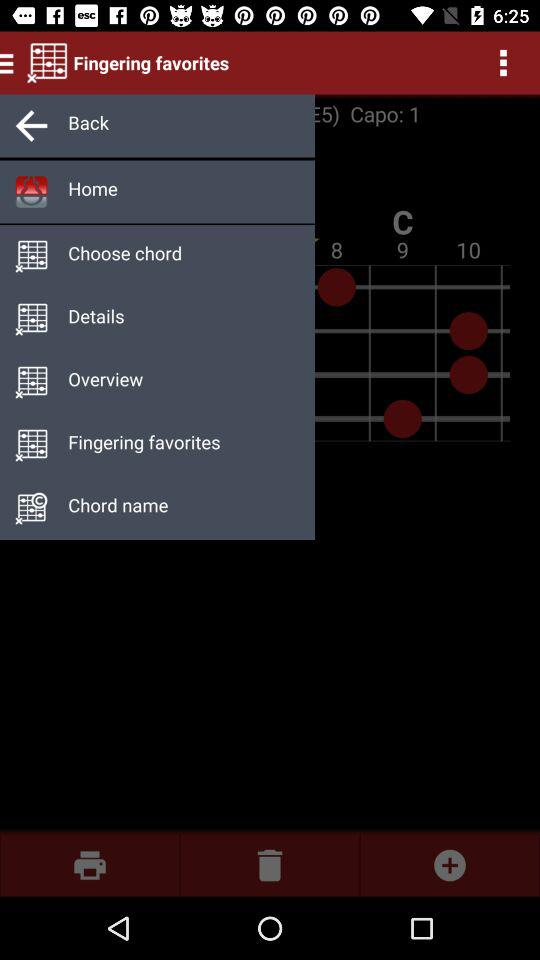What is the name of the application? The name of the application is "Fingering favorites". 